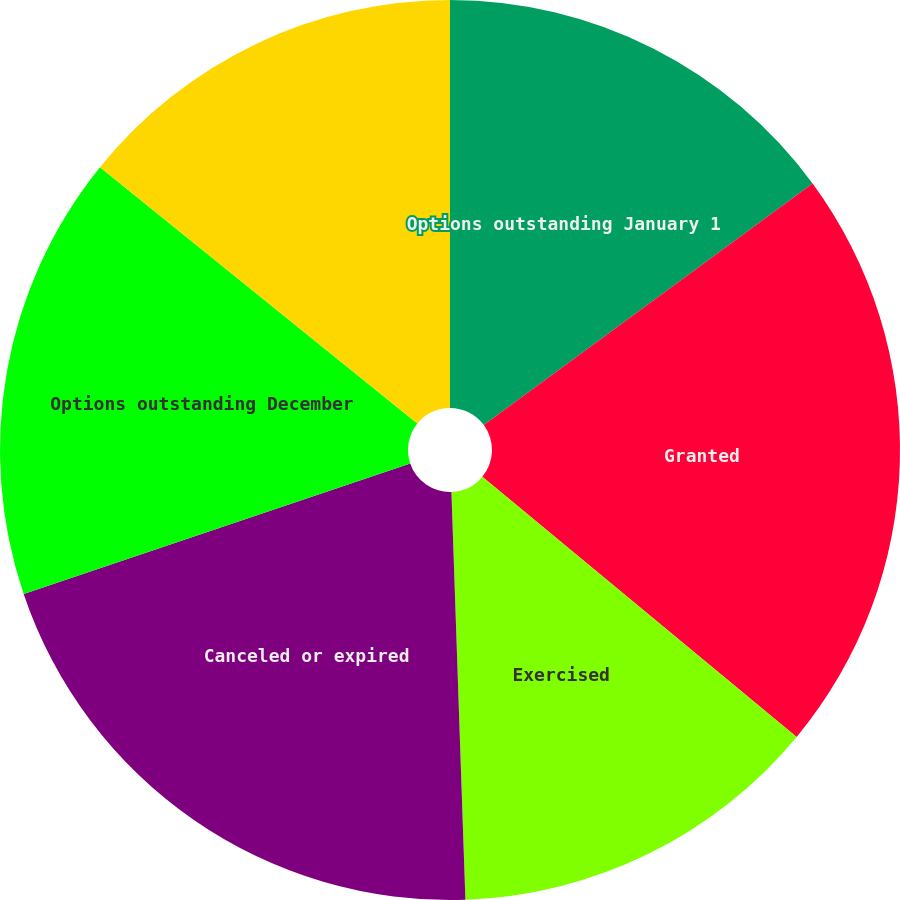Convert chart to OTSL. <chart><loc_0><loc_0><loc_500><loc_500><pie_chart><fcel>Options outstanding January 1<fcel>Granted<fcel>Exercised<fcel>Canceled or expired<fcel>Options outstanding December<fcel>Options exercisable December<nl><fcel>14.91%<fcel>21.09%<fcel>13.45%<fcel>20.36%<fcel>16.0%<fcel>14.18%<nl></chart> 